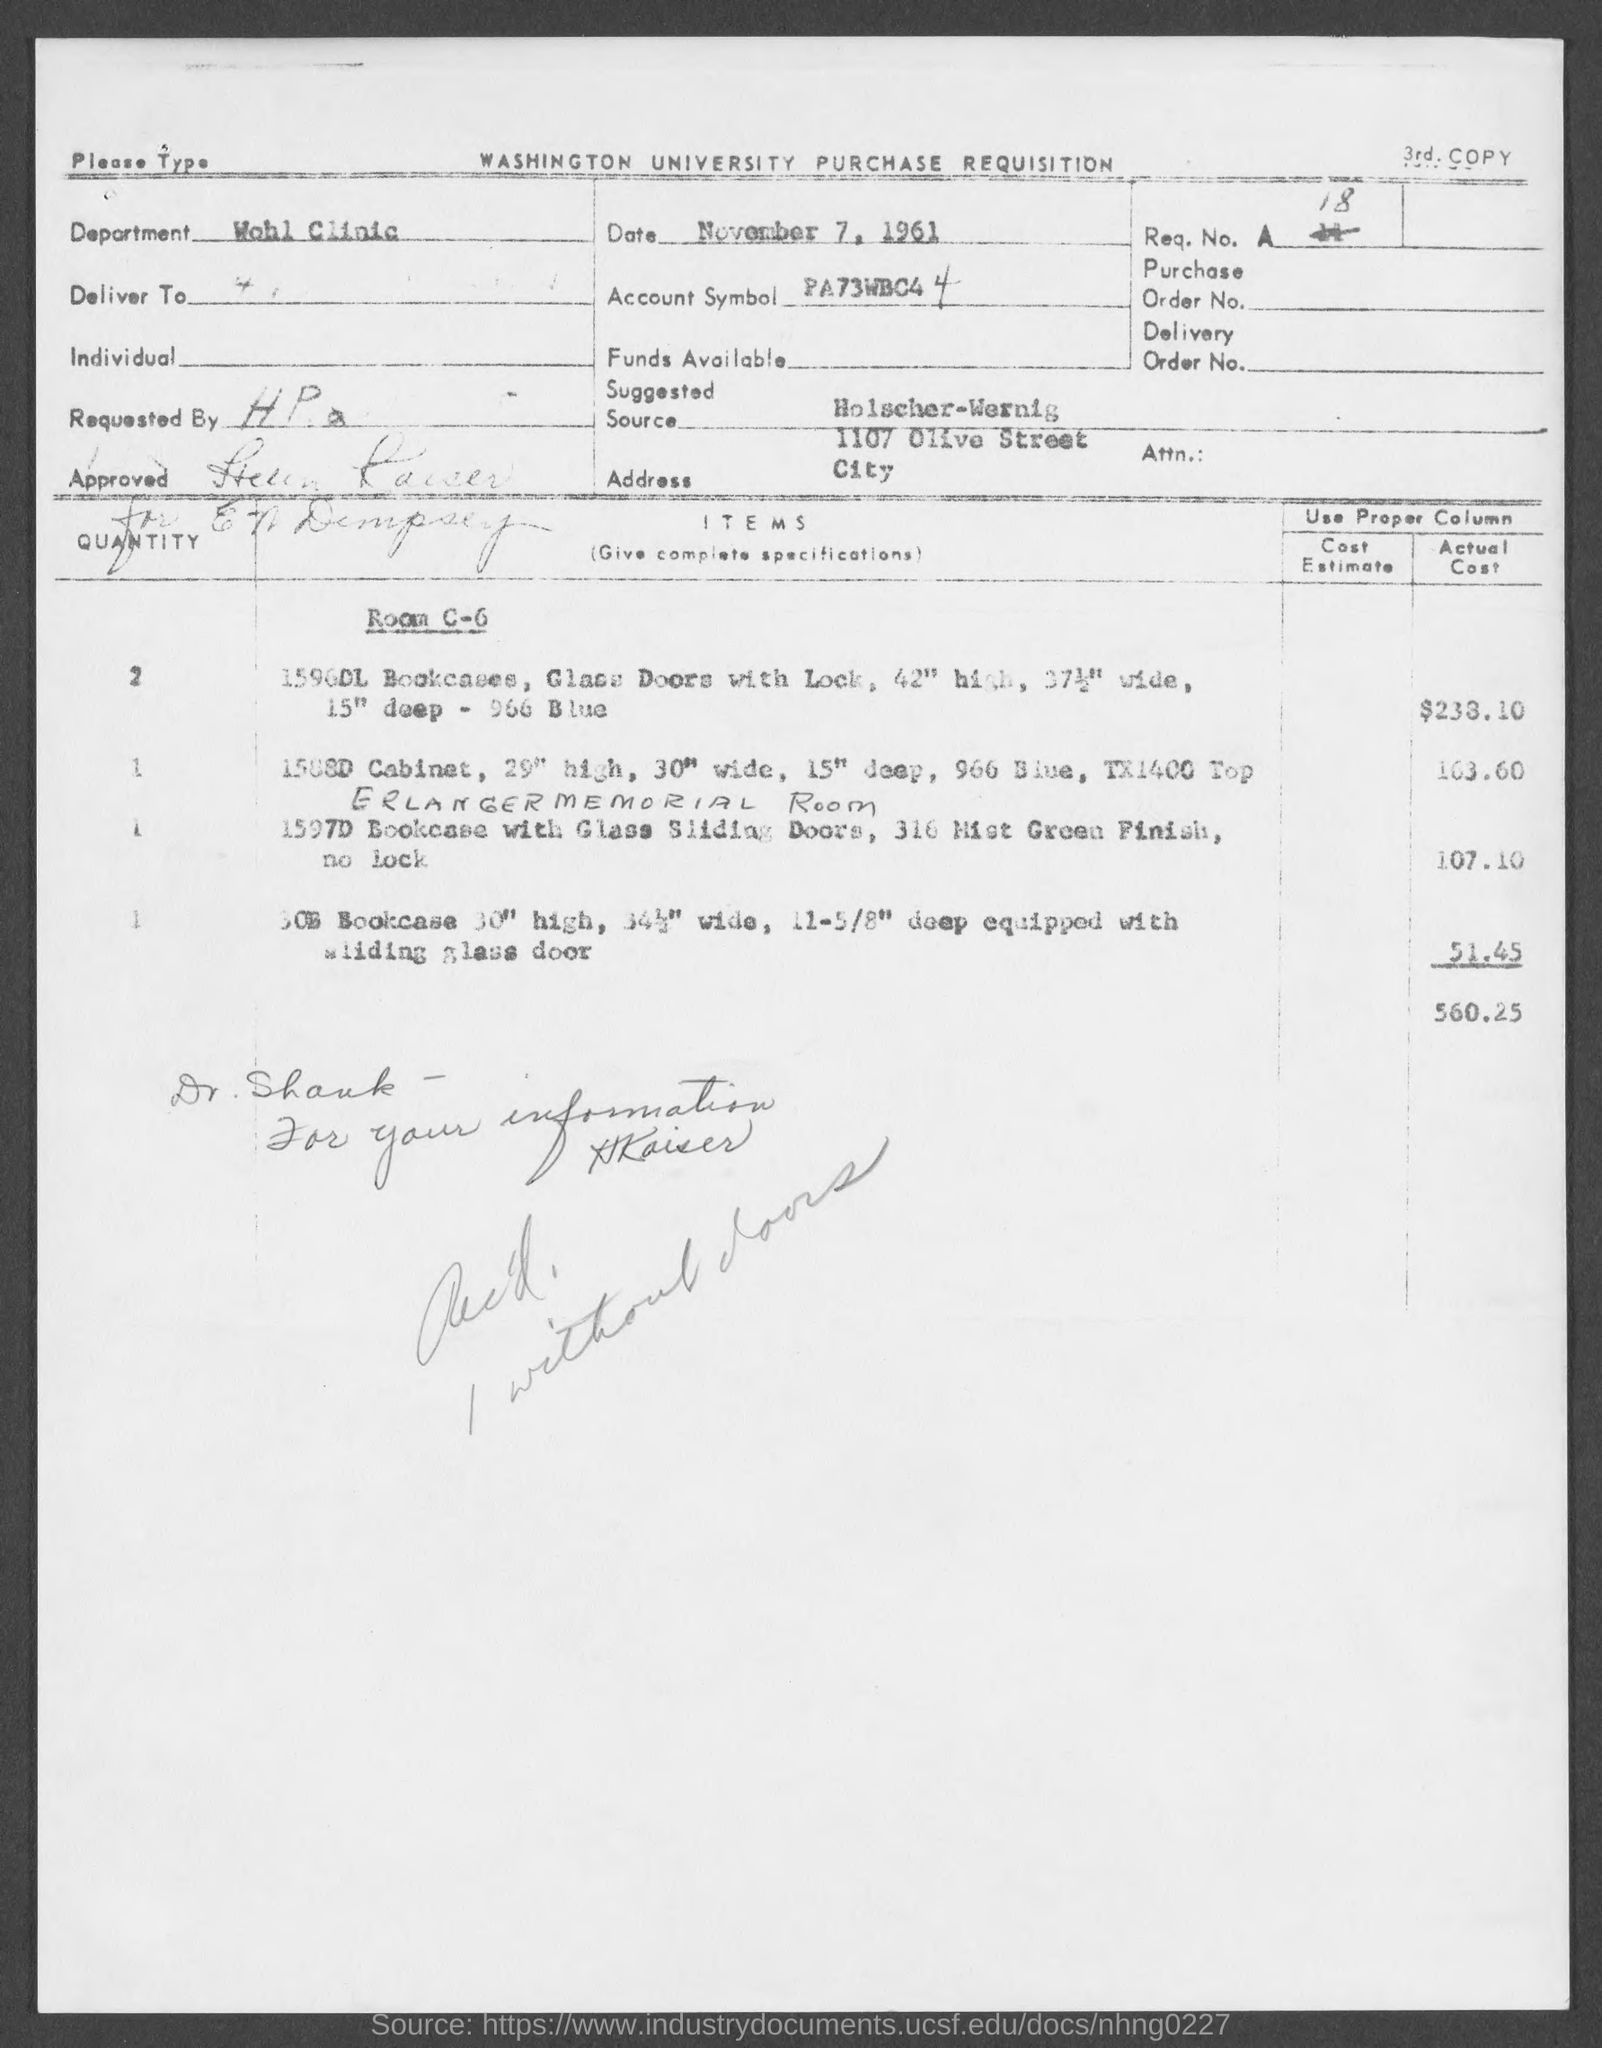Indicate a few pertinent items in this graphic. The document indicates that the date is November 7, 1961. The Wohl Clinic is the department. The suggested source is Holscher-Wernig. 